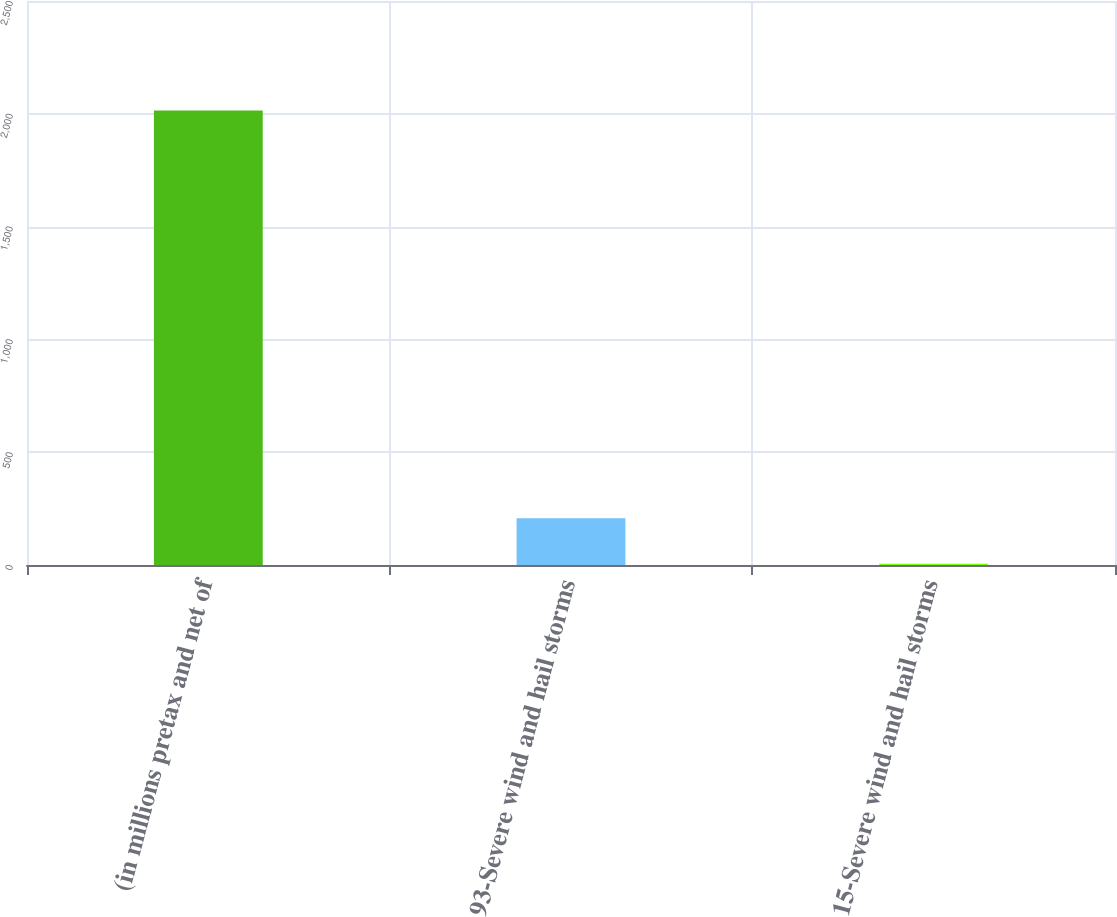Convert chart. <chart><loc_0><loc_0><loc_500><loc_500><bar_chart><fcel>(in millions pretax and net of<fcel>93-Severe wind and hail storms<fcel>15-Severe wind and hail storms<nl><fcel>2015<fcel>206.9<fcel>6<nl></chart> 